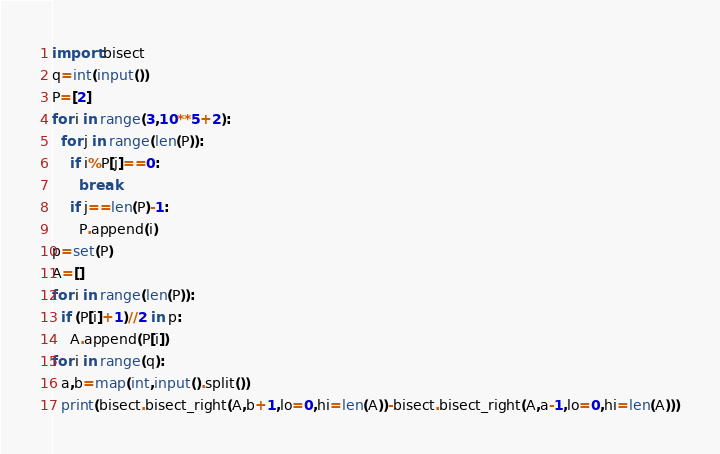Convert code to text. <code><loc_0><loc_0><loc_500><loc_500><_Python_>import bisect
q=int(input())
P=[2]
for i in range(3,10**5+2):
  for j in range(len(P)):
    if i%P[j]==0:
      break
    if j==len(P)-1:
      P.append(i)
p=set(P)
A=[]
for i in range(len(P)):
  if (P[i]+1)//2 in p:
    A.append(P[i])
for i in range(q):
  a,b=map(int,input().split())
  print(bisect.bisect_right(A,b+1,lo=0,hi=len(A))-bisect.bisect_right(A,a-1,lo=0,hi=len(A)))</code> 